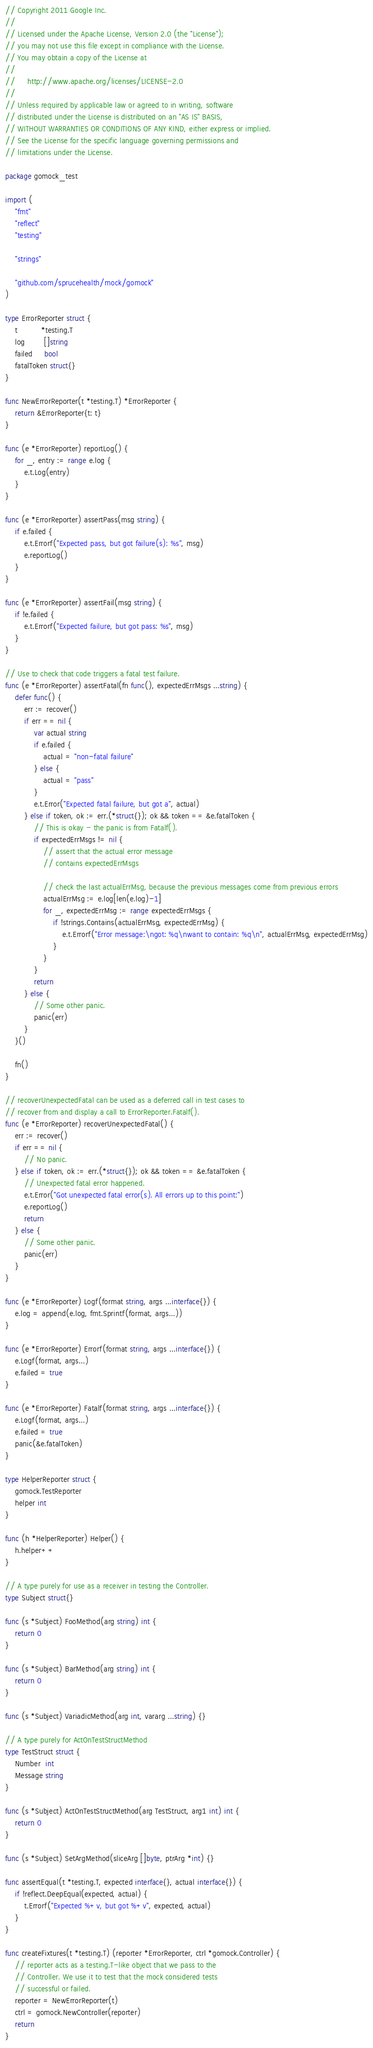Convert code to text. <code><loc_0><loc_0><loc_500><loc_500><_Go_>// Copyright 2011 Google Inc.
//
// Licensed under the Apache License, Version 2.0 (the "License");
// you may not use this file except in compliance with the License.
// You may obtain a copy of the License at
//
//     http://www.apache.org/licenses/LICENSE-2.0
//
// Unless required by applicable law or agreed to in writing, software
// distributed under the License is distributed on an "AS IS" BASIS,
// WITHOUT WARRANTIES OR CONDITIONS OF ANY KIND, either express or implied.
// See the License for the specific language governing permissions and
// limitations under the License.

package gomock_test

import (
	"fmt"
	"reflect"
	"testing"

	"strings"

	"github.com/sprucehealth/mock/gomock"
)

type ErrorReporter struct {
	t          *testing.T
	log        []string
	failed     bool
	fatalToken struct{}
}

func NewErrorReporter(t *testing.T) *ErrorReporter {
	return &ErrorReporter{t: t}
}

func (e *ErrorReporter) reportLog() {
	for _, entry := range e.log {
		e.t.Log(entry)
	}
}

func (e *ErrorReporter) assertPass(msg string) {
	if e.failed {
		e.t.Errorf("Expected pass, but got failure(s): %s", msg)
		e.reportLog()
	}
}

func (e *ErrorReporter) assertFail(msg string) {
	if !e.failed {
		e.t.Errorf("Expected failure, but got pass: %s", msg)
	}
}

// Use to check that code triggers a fatal test failure.
func (e *ErrorReporter) assertFatal(fn func(), expectedErrMsgs ...string) {
	defer func() {
		err := recover()
		if err == nil {
			var actual string
			if e.failed {
				actual = "non-fatal failure"
			} else {
				actual = "pass"
			}
			e.t.Error("Expected fatal failure, but got a", actual)
		} else if token, ok := err.(*struct{}); ok && token == &e.fatalToken {
			// This is okay - the panic is from Fatalf().
			if expectedErrMsgs != nil {
				// assert that the actual error message
				// contains expectedErrMsgs

				// check the last actualErrMsg, because the previous messages come from previous errors
				actualErrMsg := e.log[len(e.log)-1]
				for _, expectedErrMsg := range expectedErrMsgs {
					if !strings.Contains(actualErrMsg, expectedErrMsg) {
						e.t.Errorf("Error message:\ngot: %q\nwant to contain: %q\n", actualErrMsg, expectedErrMsg)
					}
				}
			}
			return
		} else {
			// Some other panic.
			panic(err)
		}
	}()

	fn()
}

// recoverUnexpectedFatal can be used as a deferred call in test cases to
// recover from and display a call to ErrorReporter.Fatalf().
func (e *ErrorReporter) recoverUnexpectedFatal() {
	err := recover()
	if err == nil {
		// No panic.
	} else if token, ok := err.(*struct{}); ok && token == &e.fatalToken {
		// Unexpected fatal error happened.
		e.t.Error("Got unexpected fatal error(s). All errors up to this point:")
		e.reportLog()
		return
	} else {
		// Some other panic.
		panic(err)
	}
}

func (e *ErrorReporter) Logf(format string, args ...interface{}) {
	e.log = append(e.log, fmt.Sprintf(format, args...))
}

func (e *ErrorReporter) Errorf(format string, args ...interface{}) {
	e.Logf(format, args...)
	e.failed = true
}

func (e *ErrorReporter) Fatalf(format string, args ...interface{}) {
	e.Logf(format, args...)
	e.failed = true
	panic(&e.fatalToken)
}

type HelperReporter struct {
	gomock.TestReporter
	helper int
}

func (h *HelperReporter) Helper() {
	h.helper++
}

// A type purely for use as a receiver in testing the Controller.
type Subject struct{}

func (s *Subject) FooMethod(arg string) int {
	return 0
}

func (s *Subject) BarMethod(arg string) int {
	return 0
}

func (s *Subject) VariadicMethod(arg int, vararg ...string) {}

// A type purely for ActOnTestStructMethod
type TestStruct struct {
	Number  int
	Message string
}

func (s *Subject) ActOnTestStructMethod(arg TestStruct, arg1 int) int {
	return 0
}

func (s *Subject) SetArgMethod(sliceArg []byte, ptrArg *int) {}

func assertEqual(t *testing.T, expected interface{}, actual interface{}) {
	if !reflect.DeepEqual(expected, actual) {
		t.Errorf("Expected %+v, but got %+v", expected, actual)
	}
}

func createFixtures(t *testing.T) (reporter *ErrorReporter, ctrl *gomock.Controller) {
	// reporter acts as a testing.T-like object that we pass to the
	// Controller. We use it to test that the mock considered tests
	// successful or failed.
	reporter = NewErrorReporter(t)
	ctrl = gomock.NewController(reporter)
	return
}
</code> 